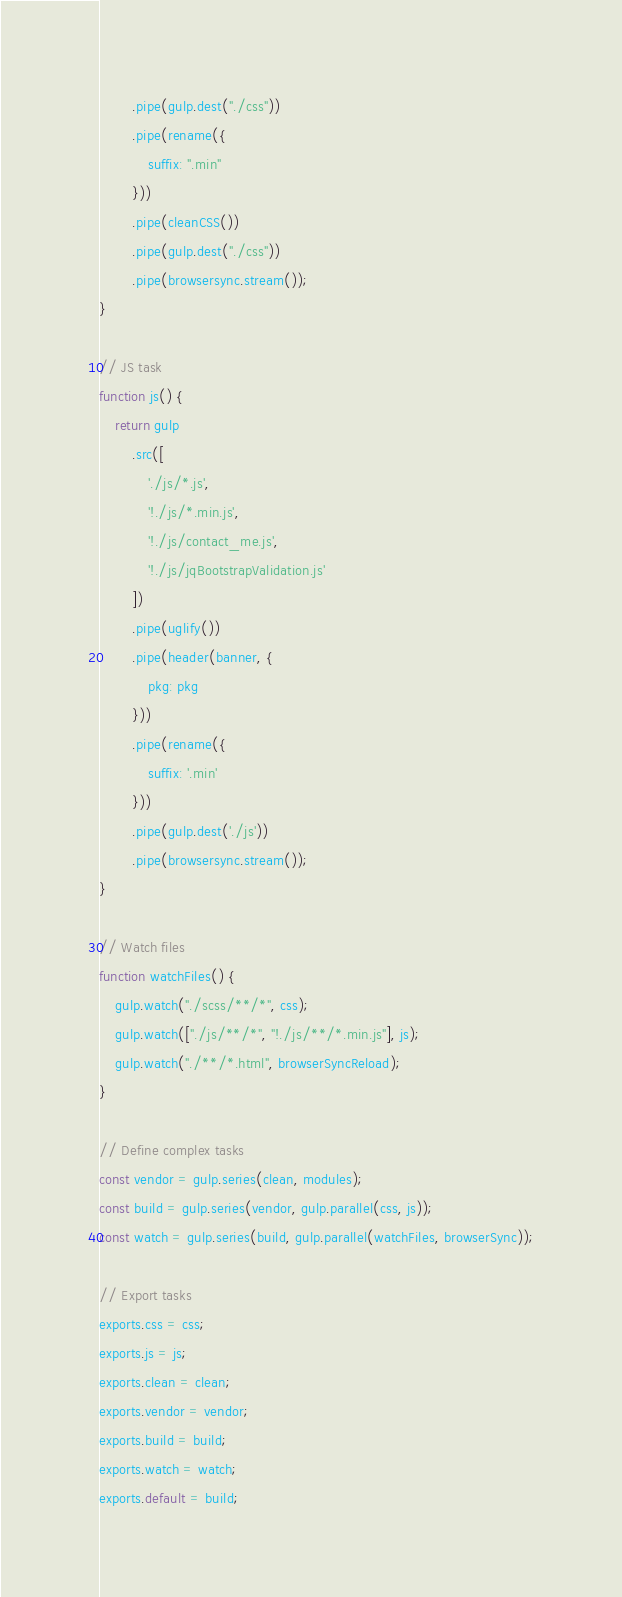Convert code to text. <code><loc_0><loc_0><loc_500><loc_500><_JavaScript_>        .pipe(gulp.dest("./css"))
        .pipe(rename({
            suffix: ".min"
        }))
        .pipe(cleanCSS())
        .pipe(gulp.dest("./css"))
        .pipe(browsersync.stream());
}

// JS task
function js() {
    return gulp
        .src([
            './js/*.js',
            '!./js/*.min.js',
            '!./js/contact_me.js',
            '!./js/jqBootstrapValidation.js'
        ])
        .pipe(uglify())
        .pipe(header(banner, {
            pkg: pkg
        }))
        .pipe(rename({
            suffix: '.min'
        }))
        .pipe(gulp.dest('./js'))
        .pipe(browsersync.stream());
}

// Watch files
function watchFiles() {
    gulp.watch("./scss/**/*", css);
    gulp.watch(["./js/**/*", "!./js/**/*.min.js"], js);
    gulp.watch("./**/*.html", browserSyncReload);
}

// Define complex tasks
const vendor = gulp.series(clean, modules);
const build = gulp.series(vendor, gulp.parallel(css, js));
const watch = gulp.series(build, gulp.parallel(watchFiles, browserSync));

// Export tasks
exports.css = css;
exports.js = js;
exports.clean = clean;
exports.vendor = vendor;
exports.build = build;
exports.watch = watch;
exports.default = build;</code> 